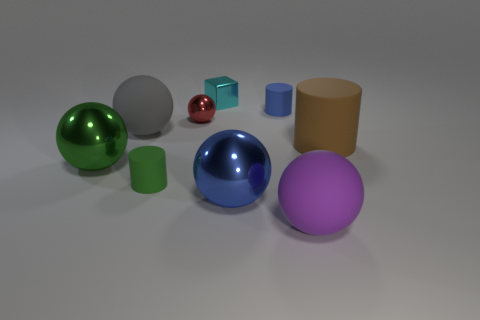Is there any other thing that is the same shape as the small cyan object?
Give a very brief answer. No. Is the number of tiny things right of the small cyan metal object greater than the number of blue shiny objects?
Make the answer very short. No. What number of other things are the same size as the cyan shiny block?
Offer a terse response. 3. Is the color of the small metallic cube the same as the small ball?
Keep it short and to the point. No. There is a big thing that is to the right of the rubber ball that is right of the big matte object that is on the left side of the shiny block; what is its color?
Provide a succinct answer. Brown. There is a large thing that is on the right side of the big sphere that is right of the tiny blue matte object; what number of large blue shiny spheres are in front of it?
Offer a terse response. 1. Are there any other things of the same color as the shiny cube?
Provide a succinct answer. No. There is a purple object right of the gray object; is it the same size as the tiny shiny sphere?
Your answer should be very brief. No. How many things are behind the matte ball that is behind the large green object?
Keep it short and to the point. 3. Is there a large matte ball right of the blue thing that is behind the matte ball that is behind the big purple rubber object?
Provide a succinct answer. Yes. 